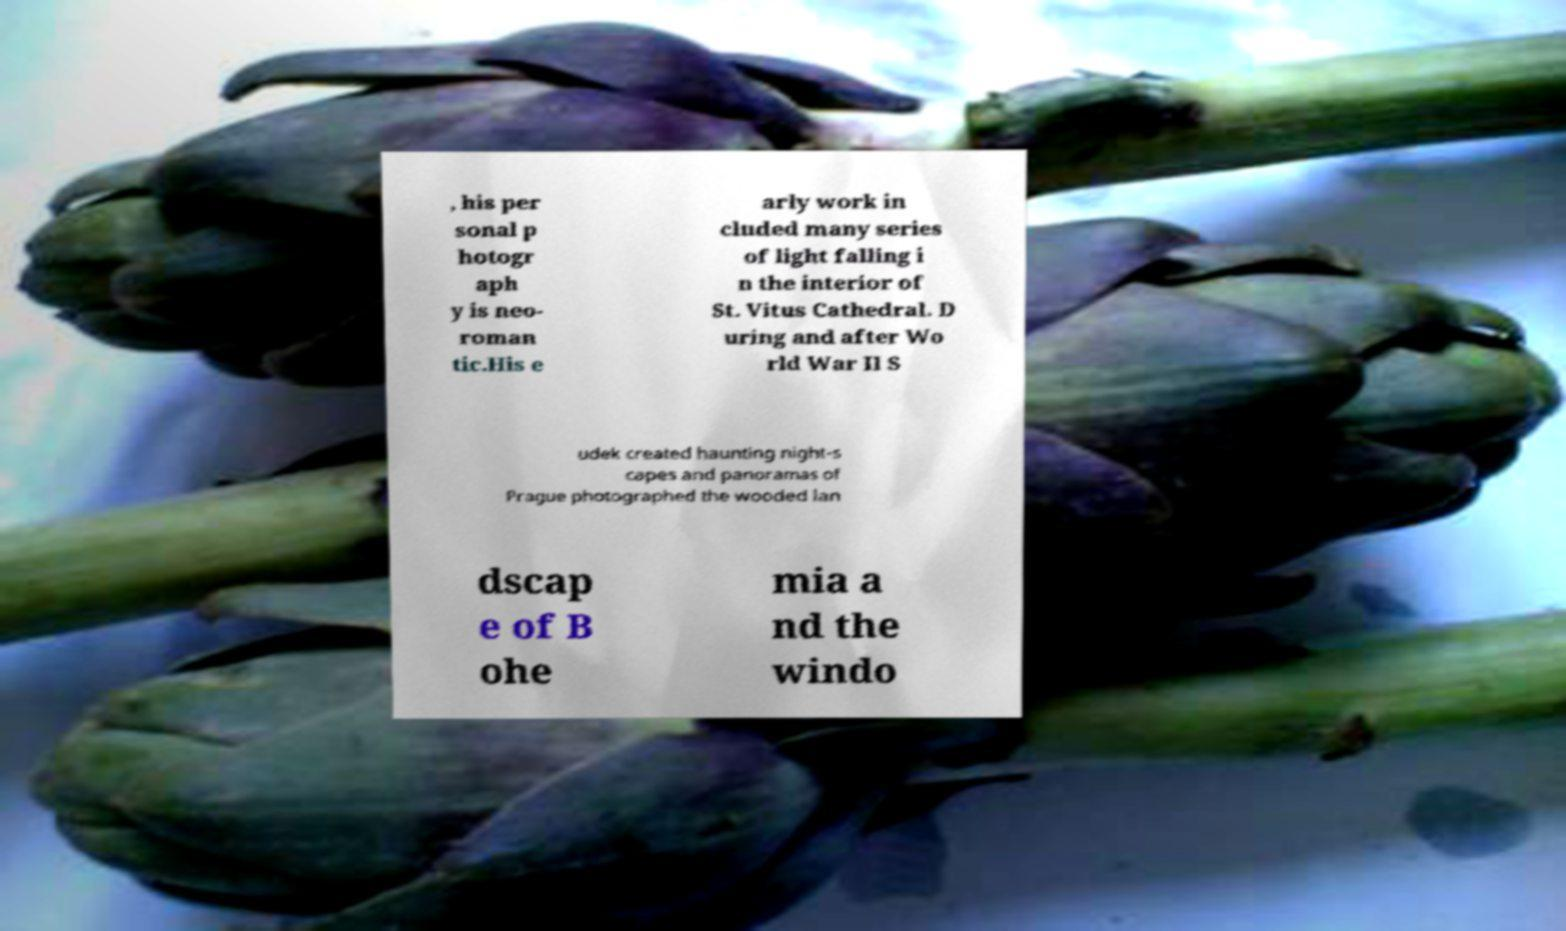For documentation purposes, I need the text within this image transcribed. Could you provide that? , his per sonal p hotogr aph y is neo- roman tic.His e arly work in cluded many series of light falling i n the interior of St. Vitus Cathedral. D uring and after Wo rld War II S udek created haunting night-s capes and panoramas of Prague photographed the wooded lan dscap e of B ohe mia a nd the windo 